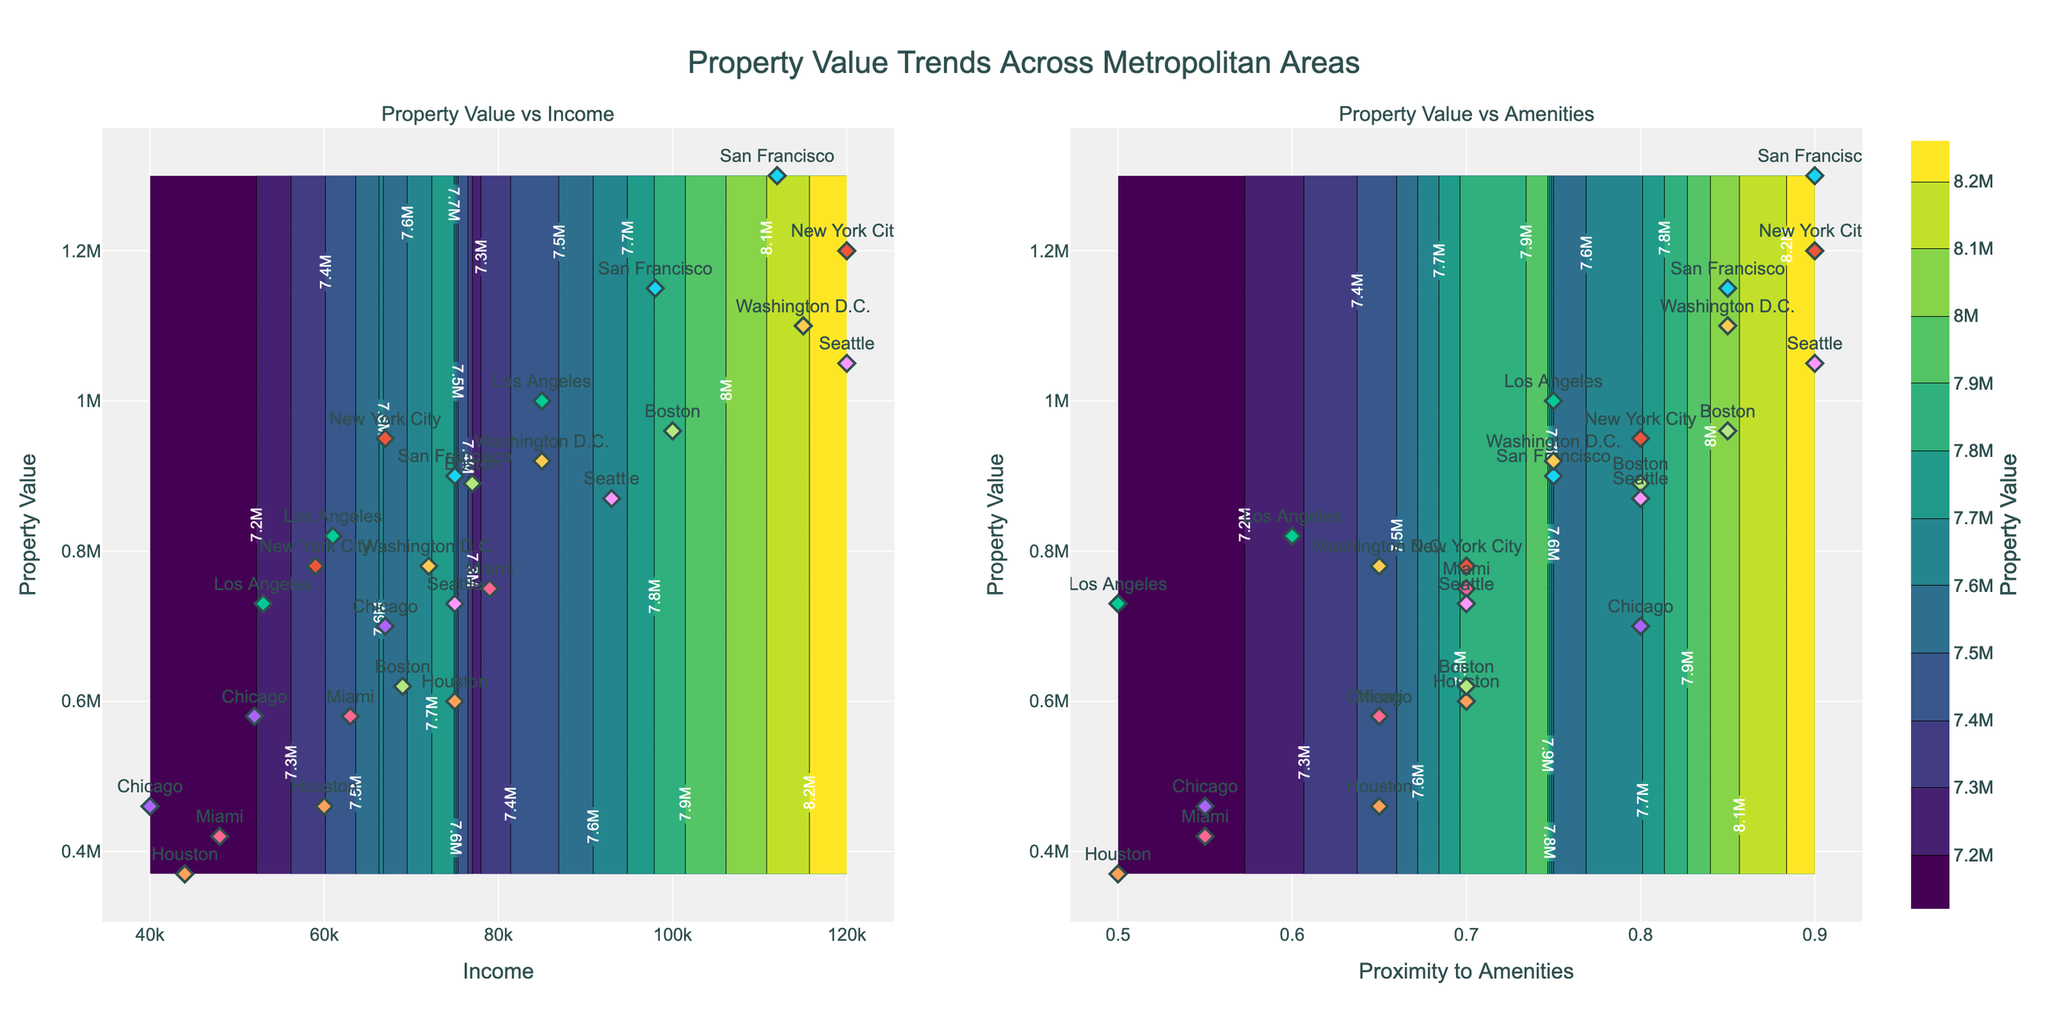How are the property values trending in relation to median income? The contour plot on the left shows property values plotted against median income. It reveals areas where property values are generally higher for higher median incomes. The trend indicates that higher median incomes correlate with higher property values.
Answer: Higher median income generally correlates with higher property values Which metropolitan area appears to have the highest property value in proximity to amenities? By examining the contour plot on the right, we can see the markers for each metropolitan area. San Francisco's markers are located towards the top-end, indicating higher property values. Its proximity to amenities is also high compared to other cities.
Answer: San Francisco What is the range of median income levels plotted in the figure? The x-axis of the left contour plot, which plots property values against median income, ranges from the lowest income (~40000) to the highest income (~120000).
Answer: Approximately 40000 to 120000 Is there any metropolitan area that shows a high property value despite a relatively lower proximity to amenities? By looking at the scatter plot markers within the right contour plot, it is evident that Los Angeles has relatively high property values (up to 1000000) despite not reaching the highest proximity to amenities (only up to 0.75).
Answer: Los Angeles Which plot shows the trend of property values more closely related to amenities rather than income? The right plot is labeled "Property Value vs Amenities," which shows how property values trend in relation to proximity to amenities rather than income. By comparing this with the left plot, you can determine that property values have a strong relation to proximity to amenities.
Answer: The right plot (Property Value vs Amenities) What pattern do you notice for Miami in terms of both median income and proximity to amenities? In the left plot (median income), Miami has data points that show moderate income levels and moderate property values. In the right plot, Miami's data points indicate a similar trend, with neither extremely high nor extremely low property values in relation to the given proximities to amenities.
Answer: Moderate property values for both income and amenities Between Seattle and Washington D.C., which metropolitan area has higher property values overall? By observing the scatter plot markers in both subplots, Seattle’s markers are more frequently at higher property values compared to Washington D.C.
Answer: Seattle Does Boston show greater variability in property values with median income or with proximity to amenities? By comparing Boston's scatter plot markers in both subplots, you can observe how these markers spread. Boston shows greater variability in the left plot (Income), indicating that property values change more widely with median income compared to amenities.
Answer: With median income Which cities have similar trends in terms of property value versus proximity to amenities? Looking at the scatter plots in the right subplot, one can see that both New York City and Boston have somewhat similar trends - their property values increase notably with proximity to amenities.
Answer: New York City and Boston 